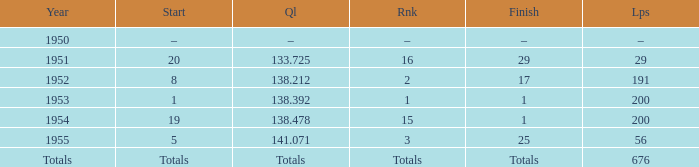What finish qualified at 141.071? 25.0. 